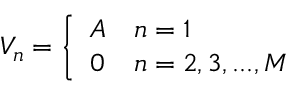Convert formula to latex. <formula><loc_0><loc_0><loc_500><loc_500>V _ { n } = \left \{ \begin{array} { c l } { A } & { n = 1 } \\ { 0 } & { n = 2 , 3 , \dots , M } \end{array}</formula> 